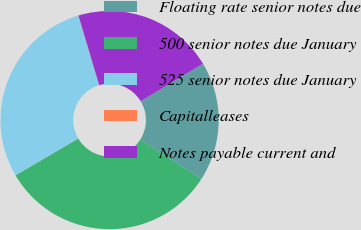<chart> <loc_0><loc_0><loc_500><loc_500><pie_chart><fcel>Floating rate senior notes due<fcel>500 senior notes due January<fcel>525 senior notes due January<fcel>Capitalleases<fcel>Notes payable current and<nl><fcel>17.71%<fcel>32.47%<fcel>28.81%<fcel>0.04%<fcel>20.96%<nl></chart> 